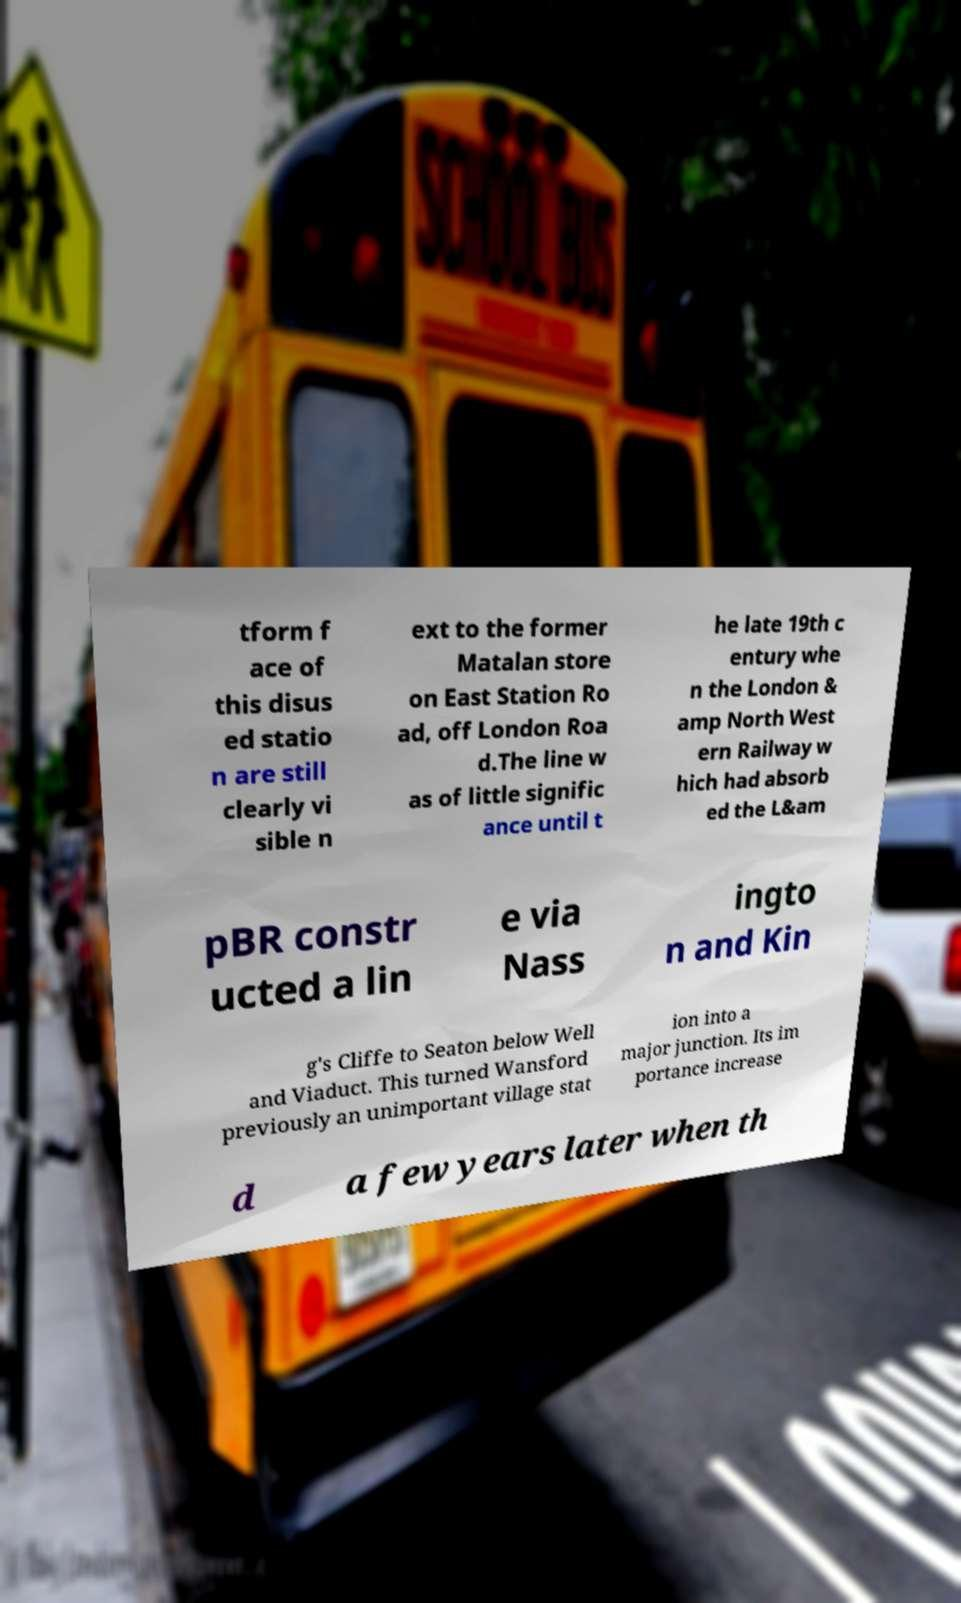Could you extract and type out the text from this image? tform f ace of this disus ed statio n are still clearly vi sible n ext to the former Matalan store on East Station Ro ad, off London Roa d.The line w as of little signific ance until t he late 19th c entury whe n the London & amp North West ern Railway w hich had absorb ed the L&am pBR constr ucted a lin e via Nass ingto n and Kin g's Cliffe to Seaton below Well and Viaduct. This turned Wansford previously an unimportant village stat ion into a major junction. Its im portance increase d a few years later when th 